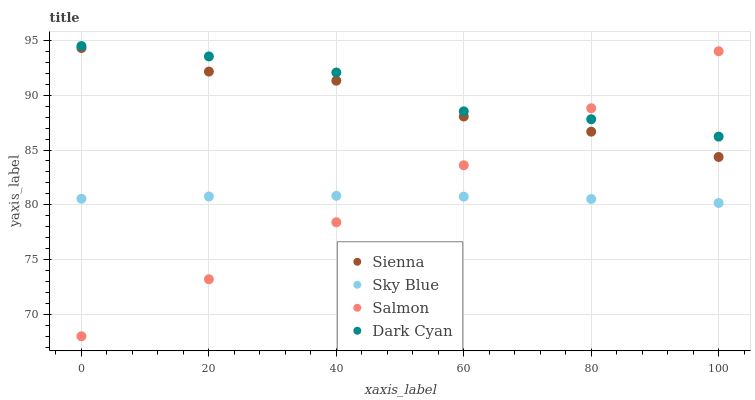Does Sky Blue have the minimum area under the curve?
Answer yes or no. Yes. Does Dark Cyan have the maximum area under the curve?
Answer yes or no. Yes. Does Salmon have the minimum area under the curve?
Answer yes or no. No. Does Salmon have the maximum area under the curve?
Answer yes or no. No. Is Salmon the smoothest?
Answer yes or no. Yes. Is Sienna the roughest?
Answer yes or no. Yes. Is Sky Blue the smoothest?
Answer yes or no. No. Is Sky Blue the roughest?
Answer yes or no. No. Does Salmon have the lowest value?
Answer yes or no. Yes. Does Sky Blue have the lowest value?
Answer yes or no. No. Does Dark Cyan have the highest value?
Answer yes or no. Yes. Does Salmon have the highest value?
Answer yes or no. No. Is Sky Blue less than Dark Cyan?
Answer yes or no. Yes. Is Dark Cyan greater than Sky Blue?
Answer yes or no. Yes. Does Salmon intersect Sky Blue?
Answer yes or no. Yes. Is Salmon less than Sky Blue?
Answer yes or no. No. Is Salmon greater than Sky Blue?
Answer yes or no. No. Does Sky Blue intersect Dark Cyan?
Answer yes or no. No. 